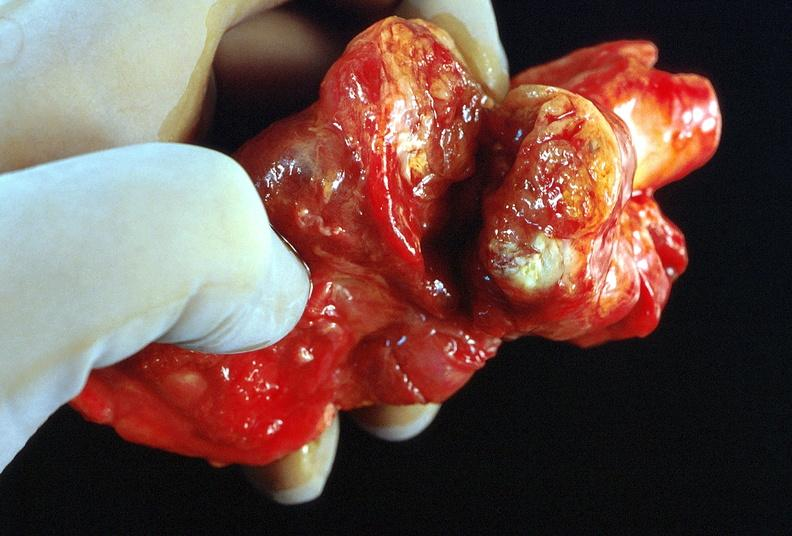does this image show thyroid, goiter?
Answer the question using a single word or phrase. Yes 